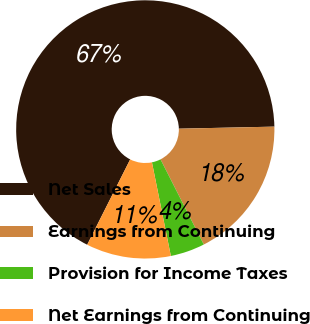Convert chart. <chart><loc_0><loc_0><loc_500><loc_500><pie_chart><fcel>Net Sales<fcel>Earnings from Continuing<fcel>Provision for Income Taxes<fcel>Net Earnings from Continuing<nl><fcel>67.23%<fcel>17.86%<fcel>4.31%<fcel>10.6%<nl></chart> 